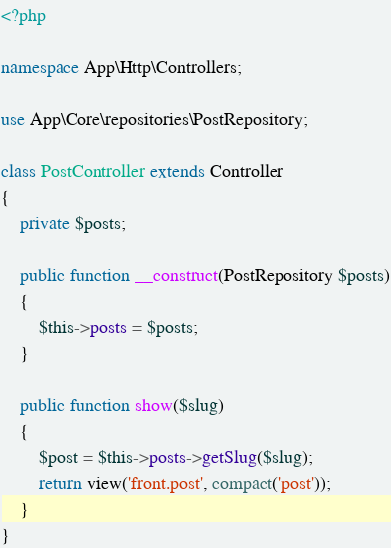Convert code to text. <code><loc_0><loc_0><loc_500><loc_500><_PHP_><?php

namespace App\Http\Controllers;

use App\Core\repositories\PostRepository;

class PostController extends Controller
{
    private $posts;

    public function __construct(PostRepository $posts)
    {
        $this->posts = $posts;
    }

    public function show($slug)
    {
        $post = $this->posts->getSlug($slug);
        return view('front.post', compact('post'));
    }
}
</code> 